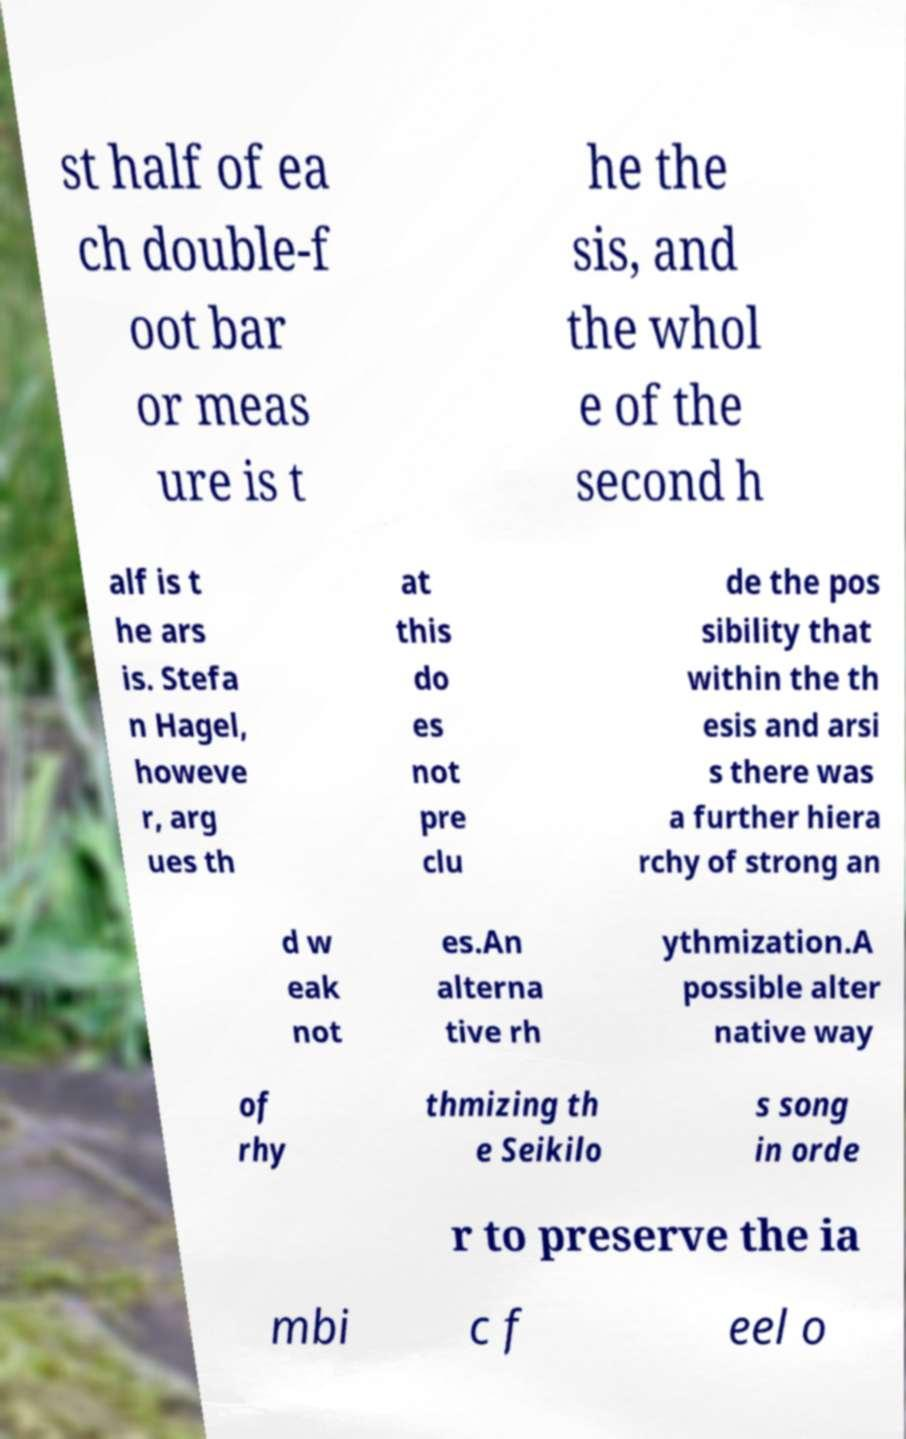Please read and relay the text visible in this image. What does it say? st half of ea ch double-f oot bar or meas ure is t he the sis, and the whol e of the second h alf is t he ars is. Stefa n Hagel, howeve r, arg ues th at this do es not pre clu de the pos sibility that within the th esis and arsi s there was a further hiera rchy of strong an d w eak not es.An alterna tive rh ythmization.A possible alter native way of rhy thmizing th e Seikilo s song in orde r to preserve the ia mbi c f eel o 